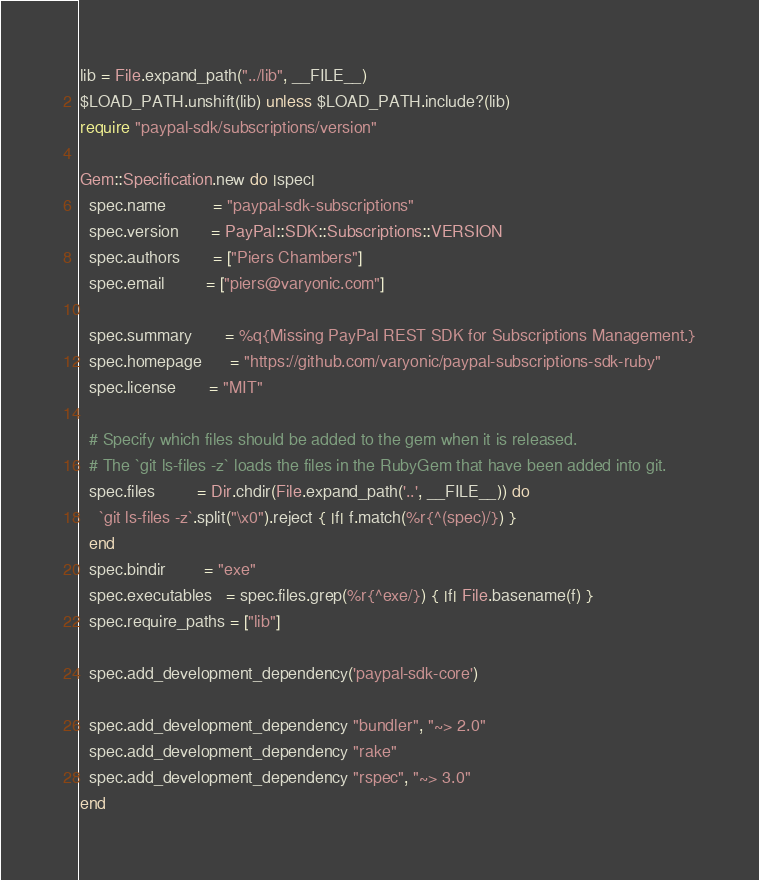<code> <loc_0><loc_0><loc_500><loc_500><_Ruby_>
lib = File.expand_path("../lib", __FILE__)
$LOAD_PATH.unshift(lib) unless $LOAD_PATH.include?(lib)
require "paypal-sdk/subscriptions/version"

Gem::Specification.new do |spec|
  spec.name          = "paypal-sdk-subscriptions"
  spec.version       = PayPal::SDK::Subscriptions::VERSION
  spec.authors       = ["Piers Chambers"]
  spec.email         = ["piers@varyonic.com"]

  spec.summary       = %q{Missing PayPal REST SDK for Subscriptions Management.}
  spec.homepage      = "https://github.com/varyonic/paypal-subscriptions-sdk-ruby"
  spec.license       = "MIT"

  # Specify which files should be added to the gem when it is released.
  # The `git ls-files -z` loads the files in the RubyGem that have been added into git.
  spec.files         = Dir.chdir(File.expand_path('..', __FILE__)) do
    `git ls-files -z`.split("\x0").reject { |f| f.match(%r{^(spec)/}) }
  end
  spec.bindir        = "exe"
  spec.executables   = spec.files.grep(%r{^exe/}) { |f| File.basename(f) }
  spec.require_paths = ["lib"]

  spec.add_development_dependency('paypal-sdk-core')

  spec.add_development_dependency "bundler", "~> 2.0"
  spec.add_development_dependency "rake"
  spec.add_development_dependency "rspec", "~> 3.0"
end
</code> 